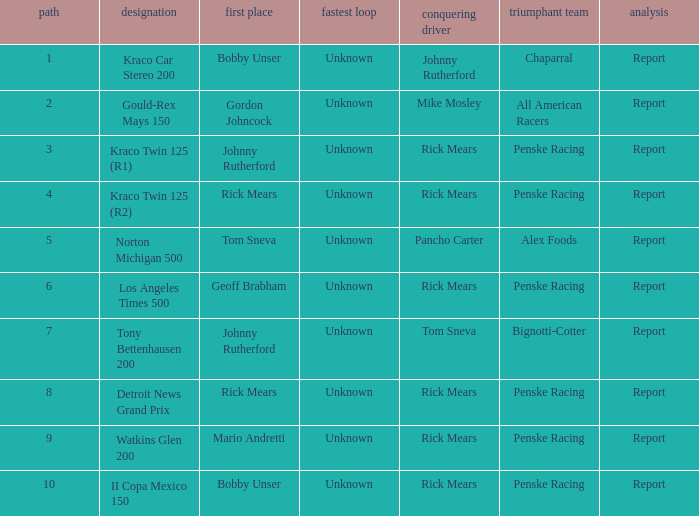How many fastest laps were there for a rd that equals 10? 1.0. 